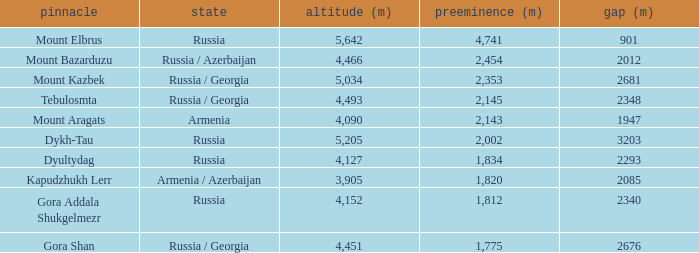With a Col (m) larger than 2012, what is Mount Kazbek's Prominence (m)? 2353.0. 